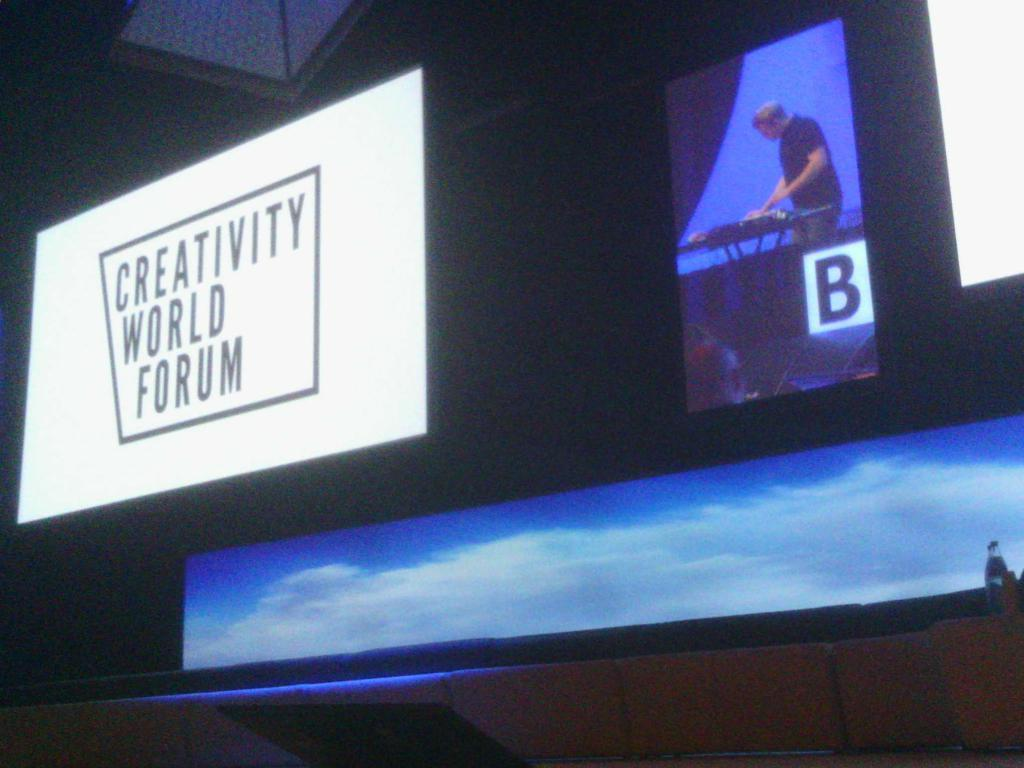<image>
Share a concise interpretation of the image provided. Creativity world forum in big on a big television with a man in the background 